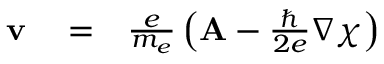<formula> <loc_0><loc_0><loc_500><loc_500>\begin{array} { r l r } { v } & = } & { { \frac { e } { m _ { e } } } \left ( { A } - { \frac { } { 2 e } } \nabla \chi \right ) } \end{array}</formula> 